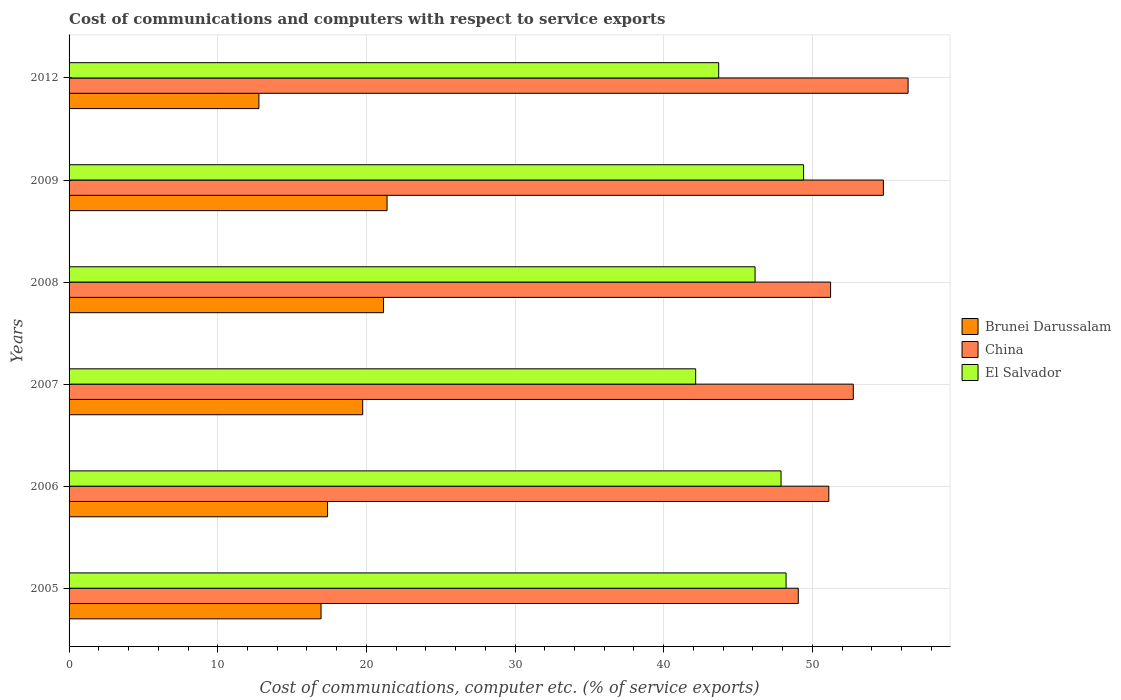How many different coloured bars are there?
Give a very brief answer. 3. Are the number of bars per tick equal to the number of legend labels?
Offer a very short reply. Yes. Are the number of bars on each tick of the Y-axis equal?
Offer a very short reply. Yes. What is the cost of communications and computers in El Salvador in 2005?
Your answer should be very brief. 48.23. Across all years, what is the maximum cost of communications and computers in China?
Keep it short and to the point. 56.44. Across all years, what is the minimum cost of communications and computers in China?
Provide a short and direct response. 49.06. What is the total cost of communications and computers in El Salvador in the graph?
Your answer should be very brief. 277.54. What is the difference between the cost of communications and computers in El Salvador in 2009 and that in 2012?
Keep it short and to the point. 5.71. What is the difference between the cost of communications and computers in El Salvador in 2005 and the cost of communications and computers in China in 2007?
Provide a succinct answer. -4.52. What is the average cost of communications and computers in Brunei Darussalam per year?
Make the answer very short. 18.23. In the year 2006, what is the difference between the cost of communications and computers in China and cost of communications and computers in Brunei Darussalam?
Give a very brief answer. 33.72. What is the ratio of the cost of communications and computers in China in 2006 to that in 2007?
Provide a short and direct response. 0.97. Is the cost of communications and computers in Brunei Darussalam in 2005 less than that in 2009?
Offer a very short reply. Yes. Is the difference between the cost of communications and computers in China in 2005 and 2007 greater than the difference between the cost of communications and computers in Brunei Darussalam in 2005 and 2007?
Offer a terse response. No. What is the difference between the highest and the second highest cost of communications and computers in Brunei Darussalam?
Ensure brevity in your answer.  0.24. What is the difference between the highest and the lowest cost of communications and computers in China?
Provide a succinct answer. 7.39. In how many years, is the cost of communications and computers in Brunei Darussalam greater than the average cost of communications and computers in Brunei Darussalam taken over all years?
Provide a short and direct response. 3. Is the sum of the cost of communications and computers in China in 2006 and 2012 greater than the maximum cost of communications and computers in El Salvador across all years?
Make the answer very short. Yes. What does the 3rd bar from the top in 2009 represents?
Ensure brevity in your answer.  Brunei Darussalam. What does the 3rd bar from the bottom in 2008 represents?
Make the answer very short. El Salvador. Are all the bars in the graph horizontal?
Give a very brief answer. Yes. What is the difference between two consecutive major ticks on the X-axis?
Your response must be concise. 10. Does the graph contain any zero values?
Keep it short and to the point. No. How are the legend labels stacked?
Provide a short and direct response. Vertical. What is the title of the graph?
Provide a short and direct response. Cost of communications and computers with respect to service exports. Does "France" appear as one of the legend labels in the graph?
Your answer should be compact. No. What is the label or title of the X-axis?
Your answer should be very brief. Cost of communications, computer etc. (% of service exports). What is the Cost of communications, computer etc. (% of service exports) of Brunei Darussalam in 2005?
Give a very brief answer. 16.95. What is the Cost of communications, computer etc. (% of service exports) of China in 2005?
Give a very brief answer. 49.06. What is the Cost of communications, computer etc. (% of service exports) of El Salvador in 2005?
Give a very brief answer. 48.23. What is the Cost of communications, computer etc. (% of service exports) in Brunei Darussalam in 2006?
Ensure brevity in your answer.  17.39. What is the Cost of communications, computer etc. (% of service exports) in China in 2006?
Keep it short and to the point. 51.11. What is the Cost of communications, computer etc. (% of service exports) in El Salvador in 2006?
Your answer should be very brief. 47.89. What is the Cost of communications, computer etc. (% of service exports) of Brunei Darussalam in 2007?
Give a very brief answer. 19.75. What is the Cost of communications, computer etc. (% of service exports) of China in 2007?
Your answer should be very brief. 52.76. What is the Cost of communications, computer etc. (% of service exports) of El Salvador in 2007?
Your response must be concise. 42.15. What is the Cost of communications, computer etc. (% of service exports) in Brunei Darussalam in 2008?
Offer a very short reply. 21.15. What is the Cost of communications, computer etc. (% of service exports) of China in 2008?
Provide a succinct answer. 51.23. What is the Cost of communications, computer etc. (% of service exports) of El Salvador in 2008?
Your answer should be very brief. 46.15. What is the Cost of communications, computer etc. (% of service exports) in Brunei Darussalam in 2009?
Your answer should be very brief. 21.39. What is the Cost of communications, computer etc. (% of service exports) of China in 2009?
Offer a very short reply. 54.78. What is the Cost of communications, computer etc. (% of service exports) of El Salvador in 2009?
Ensure brevity in your answer.  49.41. What is the Cost of communications, computer etc. (% of service exports) in Brunei Darussalam in 2012?
Your answer should be very brief. 12.77. What is the Cost of communications, computer etc. (% of service exports) in China in 2012?
Give a very brief answer. 56.44. What is the Cost of communications, computer etc. (% of service exports) in El Salvador in 2012?
Provide a short and direct response. 43.7. Across all years, what is the maximum Cost of communications, computer etc. (% of service exports) in Brunei Darussalam?
Your answer should be compact. 21.39. Across all years, what is the maximum Cost of communications, computer etc. (% of service exports) in China?
Offer a very short reply. 56.44. Across all years, what is the maximum Cost of communications, computer etc. (% of service exports) in El Salvador?
Offer a terse response. 49.41. Across all years, what is the minimum Cost of communications, computer etc. (% of service exports) in Brunei Darussalam?
Offer a terse response. 12.77. Across all years, what is the minimum Cost of communications, computer etc. (% of service exports) of China?
Your answer should be very brief. 49.06. Across all years, what is the minimum Cost of communications, computer etc. (% of service exports) in El Salvador?
Provide a succinct answer. 42.15. What is the total Cost of communications, computer etc. (% of service exports) of Brunei Darussalam in the graph?
Provide a short and direct response. 109.41. What is the total Cost of communications, computer etc. (% of service exports) in China in the graph?
Provide a succinct answer. 315.36. What is the total Cost of communications, computer etc. (% of service exports) of El Salvador in the graph?
Your answer should be very brief. 277.54. What is the difference between the Cost of communications, computer etc. (% of service exports) in Brunei Darussalam in 2005 and that in 2006?
Offer a terse response. -0.44. What is the difference between the Cost of communications, computer etc. (% of service exports) in China in 2005 and that in 2006?
Keep it short and to the point. -2.05. What is the difference between the Cost of communications, computer etc. (% of service exports) of El Salvador in 2005 and that in 2006?
Give a very brief answer. 0.34. What is the difference between the Cost of communications, computer etc. (% of service exports) of Brunei Darussalam in 2005 and that in 2007?
Your answer should be compact. -2.8. What is the difference between the Cost of communications, computer etc. (% of service exports) of China in 2005 and that in 2007?
Provide a succinct answer. -3.7. What is the difference between the Cost of communications, computer etc. (% of service exports) in El Salvador in 2005 and that in 2007?
Offer a very short reply. 6.08. What is the difference between the Cost of communications, computer etc. (% of service exports) in Brunei Darussalam in 2005 and that in 2008?
Your response must be concise. -4.2. What is the difference between the Cost of communications, computer etc. (% of service exports) in China in 2005 and that in 2008?
Offer a terse response. -2.17. What is the difference between the Cost of communications, computer etc. (% of service exports) of El Salvador in 2005 and that in 2008?
Ensure brevity in your answer.  2.09. What is the difference between the Cost of communications, computer etc. (% of service exports) of Brunei Darussalam in 2005 and that in 2009?
Ensure brevity in your answer.  -4.44. What is the difference between the Cost of communications, computer etc. (% of service exports) in China in 2005 and that in 2009?
Your answer should be compact. -5.72. What is the difference between the Cost of communications, computer etc. (% of service exports) of El Salvador in 2005 and that in 2009?
Keep it short and to the point. -1.18. What is the difference between the Cost of communications, computer etc. (% of service exports) in Brunei Darussalam in 2005 and that in 2012?
Offer a terse response. 4.18. What is the difference between the Cost of communications, computer etc. (% of service exports) in China in 2005 and that in 2012?
Provide a short and direct response. -7.39. What is the difference between the Cost of communications, computer etc. (% of service exports) in El Salvador in 2005 and that in 2012?
Offer a very short reply. 4.53. What is the difference between the Cost of communications, computer etc. (% of service exports) of Brunei Darussalam in 2006 and that in 2007?
Make the answer very short. -2.37. What is the difference between the Cost of communications, computer etc. (% of service exports) of China in 2006 and that in 2007?
Make the answer very short. -1.65. What is the difference between the Cost of communications, computer etc. (% of service exports) in El Salvador in 2006 and that in 2007?
Ensure brevity in your answer.  5.74. What is the difference between the Cost of communications, computer etc. (% of service exports) of Brunei Darussalam in 2006 and that in 2008?
Offer a terse response. -3.77. What is the difference between the Cost of communications, computer etc. (% of service exports) in China in 2006 and that in 2008?
Your answer should be compact. -0.12. What is the difference between the Cost of communications, computer etc. (% of service exports) in El Salvador in 2006 and that in 2008?
Offer a very short reply. 1.75. What is the difference between the Cost of communications, computer etc. (% of service exports) in Brunei Darussalam in 2006 and that in 2009?
Your answer should be very brief. -4. What is the difference between the Cost of communications, computer etc. (% of service exports) of China in 2006 and that in 2009?
Your answer should be compact. -3.67. What is the difference between the Cost of communications, computer etc. (% of service exports) in El Salvador in 2006 and that in 2009?
Your answer should be very brief. -1.52. What is the difference between the Cost of communications, computer etc. (% of service exports) of Brunei Darussalam in 2006 and that in 2012?
Your response must be concise. 4.62. What is the difference between the Cost of communications, computer etc. (% of service exports) of China in 2006 and that in 2012?
Your response must be concise. -5.33. What is the difference between the Cost of communications, computer etc. (% of service exports) in El Salvador in 2006 and that in 2012?
Offer a terse response. 4.2. What is the difference between the Cost of communications, computer etc. (% of service exports) of Brunei Darussalam in 2007 and that in 2008?
Your answer should be very brief. -1.4. What is the difference between the Cost of communications, computer etc. (% of service exports) of China in 2007 and that in 2008?
Provide a succinct answer. 1.53. What is the difference between the Cost of communications, computer etc. (% of service exports) of El Salvador in 2007 and that in 2008?
Provide a succinct answer. -4. What is the difference between the Cost of communications, computer etc. (% of service exports) in Brunei Darussalam in 2007 and that in 2009?
Ensure brevity in your answer.  -1.64. What is the difference between the Cost of communications, computer etc. (% of service exports) in China in 2007 and that in 2009?
Keep it short and to the point. -2.02. What is the difference between the Cost of communications, computer etc. (% of service exports) in El Salvador in 2007 and that in 2009?
Offer a terse response. -7.26. What is the difference between the Cost of communications, computer etc. (% of service exports) of Brunei Darussalam in 2007 and that in 2012?
Offer a terse response. 6.98. What is the difference between the Cost of communications, computer etc. (% of service exports) in China in 2007 and that in 2012?
Offer a terse response. -3.69. What is the difference between the Cost of communications, computer etc. (% of service exports) in El Salvador in 2007 and that in 2012?
Ensure brevity in your answer.  -1.55. What is the difference between the Cost of communications, computer etc. (% of service exports) in Brunei Darussalam in 2008 and that in 2009?
Your answer should be compact. -0.24. What is the difference between the Cost of communications, computer etc. (% of service exports) of China in 2008 and that in 2009?
Ensure brevity in your answer.  -3.55. What is the difference between the Cost of communications, computer etc. (% of service exports) of El Salvador in 2008 and that in 2009?
Keep it short and to the point. -3.26. What is the difference between the Cost of communications, computer etc. (% of service exports) in Brunei Darussalam in 2008 and that in 2012?
Offer a very short reply. 8.38. What is the difference between the Cost of communications, computer etc. (% of service exports) of China in 2008 and that in 2012?
Give a very brief answer. -5.21. What is the difference between the Cost of communications, computer etc. (% of service exports) of El Salvador in 2008 and that in 2012?
Your answer should be compact. 2.45. What is the difference between the Cost of communications, computer etc. (% of service exports) in Brunei Darussalam in 2009 and that in 2012?
Ensure brevity in your answer.  8.62. What is the difference between the Cost of communications, computer etc. (% of service exports) of China in 2009 and that in 2012?
Your answer should be compact. -1.66. What is the difference between the Cost of communications, computer etc. (% of service exports) in El Salvador in 2009 and that in 2012?
Offer a terse response. 5.71. What is the difference between the Cost of communications, computer etc. (% of service exports) of Brunei Darussalam in 2005 and the Cost of communications, computer etc. (% of service exports) of China in 2006?
Give a very brief answer. -34.16. What is the difference between the Cost of communications, computer etc. (% of service exports) in Brunei Darussalam in 2005 and the Cost of communications, computer etc. (% of service exports) in El Salvador in 2006?
Your answer should be compact. -30.94. What is the difference between the Cost of communications, computer etc. (% of service exports) in China in 2005 and the Cost of communications, computer etc. (% of service exports) in El Salvador in 2006?
Your response must be concise. 1.16. What is the difference between the Cost of communications, computer etc. (% of service exports) in Brunei Darussalam in 2005 and the Cost of communications, computer etc. (% of service exports) in China in 2007?
Make the answer very short. -35.8. What is the difference between the Cost of communications, computer etc. (% of service exports) in Brunei Darussalam in 2005 and the Cost of communications, computer etc. (% of service exports) in El Salvador in 2007?
Offer a terse response. -25.2. What is the difference between the Cost of communications, computer etc. (% of service exports) of China in 2005 and the Cost of communications, computer etc. (% of service exports) of El Salvador in 2007?
Ensure brevity in your answer.  6.9. What is the difference between the Cost of communications, computer etc. (% of service exports) of Brunei Darussalam in 2005 and the Cost of communications, computer etc. (% of service exports) of China in 2008?
Keep it short and to the point. -34.28. What is the difference between the Cost of communications, computer etc. (% of service exports) in Brunei Darussalam in 2005 and the Cost of communications, computer etc. (% of service exports) in El Salvador in 2008?
Give a very brief answer. -29.2. What is the difference between the Cost of communications, computer etc. (% of service exports) of China in 2005 and the Cost of communications, computer etc. (% of service exports) of El Salvador in 2008?
Offer a terse response. 2.91. What is the difference between the Cost of communications, computer etc. (% of service exports) in Brunei Darussalam in 2005 and the Cost of communications, computer etc. (% of service exports) in China in 2009?
Keep it short and to the point. -37.83. What is the difference between the Cost of communications, computer etc. (% of service exports) in Brunei Darussalam in 2005 and the Cost of communications, computer etc. (% of service exports) in El Salvador in 2009?
Offer a terse response. -32.46. What is the difference between the Cost of communications, computer etc. (% of service exports) of China in 2005 and the Cost of communications, computer etc. (% of service exports) of El Salvador in 2009?
Your answer should be compact. -0.36. What is the difference between the Cost of communications, computer etc. (% of service exports) of Brunei Darussalam in 2005 and the Cost of communications, computer etc. (% of service exports) of China in 2012?
Provide a succinct answer. -39.49. What is the difference between the Cost of communications, computer etc. (% of service exports) in Brunei Darussalam in 2005 and the Cost of communications, computer etc. (% of service exports) in El Salvador in 2012?
Provide a succinct answer. -26.75. What is the difference between the Cost of communications, computer etc. (% of service exports) of China in 2005 and the Cost of communications, computer etc. (% of service exports) of El Salvador in 2012?
Provide a succinct answer. 5.36. What is the difference between the Cost of communications, computer etc. (% of service exports) in Brunei Darussalam in 2006 and the Cost of communications, computer etc. (% of service exports) in China in 2007?
Ensure brevity in your answer.  -35.37. What is the difference between the Cost of communications, computer etc. (% of service exports) of Brunei Darussalam in 2006 and the Cost of communications, computer etc. (% of service exports) of El Salvador in 2007?
Give a very brief answer. -24.76. What is the difference between the Cost of communications, computer etc. (% of service exports) in China in 2006 and the Cost of communications, computer etc. (% of service exports) in El Salvador in 2007?
Ensure brevity in your answer.  8.96. What is the difference between the Cost of communications, computer etc. (% of service exports) of Brunei Darussalam in 2006 and the Cost of communications, computer etc. (% of service exports) of China in 2008?
Ensure brevity in your answer.  -33.84. What is the difference between the Cost of communications, computer etc. (% of service exports) in Brunei Darussalam in 2006 and the Cost of communications, computer etc. (% of service exports) in El Salvador in 2008?
Give a very brief answer. -28.76. What is the difference between the Cost of communications, computer etc. (% of service exports) of China in 2006 and the Cost of communications, computer etc. (% of service exports) of El Salvador in 2008?
Your response must be concise. 4.96. What is the difference between the Cost of communications, computer etc. (% of service exports) in Brunei Darussalam in 2006 and the Cost of communications, computer etc. (% of service exports) in China in 2009?
Provide a short and direct response. -37.39. What is the difference between the Cost of communications, computer etc. (% of service exports) in Brunei Darussalam in 2006 and the Cost of communications, computer etc. (% of service exports) in El Salvador in 2009?
Provide a succinct answer. -32.02. What is the difference between the Cost of communications, computer etc. (% of service exports) of China in 2006 and the Cost of communications, computer etc. (% of service exports) of El Salvador in 2009?
Make the answer very short. 1.7. What is the difference between the Cost of communications, computer etc. (% of service exports) in Brunei Darussalam in 2006 and the Cost of communications, computer etc. (% of service exports) in China in 2012?
Ensure brevity in your answer.  -39.05. What is the difference between the Cost of communications, computer etc. (% of service exports) of Brunei Darussalam in 2006 and the Cost of communications, computer etc. (% of service exports) of El Salvador in 2012?
Offer a very short reply. -26.31. What is the difference between the Cost of communications, computer etc. (% of service exports) in China in 2006 and the Cost of communications, computer etc. (% of service exports) in El Salvador in 2012?
Offer a terse response. 7.41. What is the difference between the Cost of communications, computer etc. (% of service exports) of Brunei Darussalam in 2007 and the Cost of communications, computer etc. (% of service exports) of China in 2008?
Offer a terse response. -31.47. What is the difference between the Cost of communications, computer etc. (% of service exports) of Brunei Darussalam in 2007 and the Cost of communications, computer etc. (% of service exports) of El Salvador in 2008?
Provide a short and direct response. -26.39. What is the difference between the Cost of communications, computer etc. (% of service exports) in China in 2007 and the Cost of communications, computer etc. (% of service exports) in El Salvador in 2008?
Your answer should be very brief. 6.61. What is the difference between the Cost of communications, computer etc. (% of service exports) in Brunei Darussalam in 2007 and the Cost of communications, computer etc. (% of service exports) in China in 2009?
Provide a succinct answer. -35.02. What is the difference between the Cost of communications, computer etc. (% of service exports) of Brunei Darussalam in 2007 and the Cost of communications, computer etc. (% of service exports) of El Salvador in 2009?
Ensure brevity in your answer.  -29.66. What is the difference between the Cost of communications, computer etc. (% of service exports) in China in 2007 and the Cost of communications, computer etc. (% of service exports) in El Salvador in 2009?
Make the answer very short. 3.34. What is the difference between the Cost of communications, computer etc. (% of service exports) of Brunei Darussalam in 2007 and the Cost of communications, computer etc. (% of service exports) of China in 2012?
Provide a succinct answer. -36.69. What is the difference between the Cost of communications, computer etc. (% of service exports) of Brunei Darussalam in 2007 and the Cost of communications, computer etc. (% of service exports) of El Salvador in 2012?
Your answer should be compact. -23.95. What is the difference between the Cost of communications, computer etc. (% of service exports) in China in 2007 and the Cost of communications, computer etc. (% of service exports) in El Salvador in 2012?
Make the answer very short. 9.06. What is the difference between the Cost of communications, computer etc. (% of service exports) of Brunei Darussalam in 2008 and the Cost of communications, computer etc. (% of service exports) of China in 2009?
Provide a short and direct response. -33.62. What is the difference between the Cost of communications, computer etc. (% of service exports) in Brunei Darussalam in 2008 and the Cost of communications, computer etc. (% of service exports) in El Salvador in 2009?
Make the answer very short. -28.26. What is the difference between the Cost of communications, computer etc. (% of service exports) in China in 2008 and the Cost of communications, computer etc. (% of service exports) in El Salvador in 2009?
Your response must be concise. 1.82. What is the difference between the Cost of communications, computer etc. (% of service exports) in Brunei Darussalam in 2008 and the Cost of communications, computer etc. (% of service exports) in China in 2012?
Provide a short and direct response. -35.29. What is the difference between the Cost of communications, computer etc. (% of service exports) in Brunei Darussalam in 2008 and the Cost of communications, computer etc. (% of service exports) in El Salvador in 2012?
Your answer should be compact. -22.55. What is the difference between the Cost of communications, computer etc. (% of service exports) in China in 2008 and the Cost of communications, computer etc. (% of service exports) in El Salvador in 2012?
Provide a succinct answer. 7.53. What is the difference between the Cost of communications, computer etc. (% of service exports) in Brunei Darussalam in 2009 and the Cost of communications, computer etc. (% of service exports) in China in 2012?
Ensure brevity in your answer.  -35.05. What is the difference between the Cost of communications, computer etc. (% of service exports) in Brunei Darussalam in 2009 and the Cost of communications, computer etc. (% of service exports) in El Salvador in 2012?
Your response must be concise. -22.31. What is the difference between the Cost of communications, computer etc. (% of service exports) of China in 2009 and the Cost of communications, computer etc. (% of service exports) of El Salvador in 2012?
Offer a very short reply. 11.08. What is the average Cost of communications, computer etc. (% of service exports) of Brunei Darussalam per year?
Your answer should be very brief. 18.23. What is the average Cost of communications, computer etc. (% of service exports) in China per year?
Ensure brevity in your answer.  52.56. What is the average Cost of communications, computer etc. (% of service exports) of El Salvador per year?
Make the answer very short. 46.26. In the year 2005, what is the difference between the Cost of communications, computer etc. (% of service exports) of Brunei Darussalam and Cost of communications, computer etc. (% of service exports) of China?
Provide a succinct answer. -32.1. In the year 2005, what is the difference between the Cost of communications, computer etc. (% of service exports) of Brunei Darussalam and Cost of communications, computer etc. (% of service exports) of El Salvador?
Make the answer very short. -31.28. In the year 2005, what is the difference between the Cost of communications, computer etc. (% of service exports) of China and Cost of communications, computer etc. (% of service exports) of El Salvador?
Make the answer very short. 0.82. In the year 2006, what is the difference between the Cost of communications, computer etc. (% of service exports) in Brunei Darussalam and Cost of communications, computer etc. (% of service exports) in China?
Keep it short and to the point. -33.72. In the year 2006, what is the difference between the Cost of communications, computer etc. (% of service exports) in Brunei Darussalam and Cost of communications, computer etc. (% of service exports) in El Salvador?
Keep it short and to the point. -30.51. In the year 2006, what is the difference between the Cost of communications, computer etc. (% of service exports) in China and Cost of communications, computer etc. (% of service exports) in El Salvador?
Your response must be concise. 3.21. In the year 2007, what is the difference between the Cost of communications, computer etc. (% of service exports) in Brunei Darussalam and Cost of communications, computer etc. (% of service exports) in China?
Give a very brief answer. -33. In the year 2007, what is the difference between the Cost of communications, computer etc. (% of service exports) of Brunei Darussalam and Cost of communications, computer etc. (% of service exports) of El Salvador?
Provide a succinct answer. -22.4. In the year 2007, what is the difference between the Cost of communications, computer etc. (% of service exports) of China and Cost of communications, computer etc. (% of service exports) of El Salvador?
Your answer should be compact. 10.6. In the year 2008, what is the difference between the Cost of communications, computer etc. (% of service exports) in Brunei Darussalam and Cost of communications, computer etc. (% of service exports) in China?
Provide a short and direct response. -30.07. In the year 2008, what is the difference between the Cost of communications, computer etc. (% of service exports) of Brunei Darussalam and Cost of communications, computer etc. (% of service exports) of El Salvador?
Provide a succinct answer. -24.99. In the year 2008, what is the difference between the Cost of communications, computer etc. (% of service exports) in China and Cost of communications, computer etc. (% of service exports) in El Salvador?
Your answer should be very brief. 5.08. In the year 2009, what is the difference between the Cost of communications, computer etc. (% of service exports) of Brunei Darussalam and Cost of communications, computer etc. (% of service exports) of China?
Ensure brevity in your answer.  -33.39. In the year 2009, what is the difference between the Cost of communications, computer etc. (% of service exports) in Brunei Darussalam and Cost of communications, computer etc. (% of service exports) in El Salvador?
Offer a very short reply. -28.02. In the year 2009, what is the difference between the Cost of communications, computer etc. (% of service exports) in China and Cost of communications, computer etc. (% of service exports) in El Salvador?
Your answer should be very brief. 5.37. In the year 2012, what is the difference between the Cost of communications, computer etc. (% of service exports) in Brunei Darussalam and Cost of communications, computer etc. (% of service exports) in China?
Keep it short and to the point. -43.67. In the year 2012, what is the difference between the Cost of communications, computer etc. (% of service exports) in Brunei Darussalam and Cost of communications, computer etc. (% of service exports) in El Salvador?
Your response must be concise. -30.93. In the year 2012, what is the difference between the Cost of communications, computer etc. (% of service exports) of China and Cost of communications, computer etc. (% of service exports) of El Salvador?
Give a very brief answer. 12.74. What is the ratio of the Cost of communications, computer etc. (% of service exports) of Brunei Darussalam in 2005 to that in 2006?
Offer a terse response. 0.97. What is the ratio of the Cost of communications, computer etc. (% of service exports) of China in 2005 to that in 2006?
Provide a short and direct response. 0.96. What is the ratio of the Cost of communications, computer etc. (% of service exports) of El Salvador in 2005 to that in 2006?
Ensure brevity in your answer.  1.01. What is the ratio of the Cost of communications, computer etc. (% of service exports) in Brunei Darussalam in 2005 to that in 2007?
Keep it short and to the point. 0.86. What is the ratio of the Cost of communications, computer etc. (% of service exports) in China in 2005 to that in 2007?
Keep it short and to the point. 0.93. What is the ratio of the Cost of communications, computer etc. (% of service exports) of El Salvador in 2005 to that in 2007?
Provide a succinct answer. 1.14. What is the ratio of the Cost of communications, computer etc. (% of service exports) in Brunei Darussalam in 2005 to that in 2008?
Ensure brevity in your answer.  0.8. What is the ratio of the Cost of communications, computer etc. (% of service exports) of China in 2005 to that in 2008?
Your answer should be very brief. 0.96. What is the ratio of the Cost of communications, computer etc. (% of service exports) in El Salvador in 2005 to that in 2008?
Ensure brevity in your answer.  1.05. What is the ratio of the Cost of communications, computer etc. (% of service exports) of Brunei Darussalam in 2005 to that in 2009?
Make the answer very short. 0.79. What is the ratio of the Cost of communications, computer etc. (% of service exports) of China in 2005 to that in 2009?
Your response must be concise. 0.9. What is the ratio of the Cost of communications, computer etc. (% of service exports) of El Salvador in 2005 to that in 2009?
Your answer should be compact. 0.98. What is the ratio of the Cost of communications, computer etc. (% of service exports) of Brunei Darussalam in 2005 to that in 2012?
Your answer should be compact. 1.33. What is the ratio of the Cost of communications, computer etc. (% of service exports) of China in 2005 to that in 2012?
Keep it short and to the point. 0.87. What is the ratio of the Cost of communications, computer etc. (% of service exports) in El Salvador in 2005 to that in 2012?
Your answer should be compact. 1.1. What is the ratio of the Cost of communications, computer etc. (% of service exports) in Brunei Darussalam in 2006 to that in 2007?
Your response must be concise. 0.88. What is the ratio of the Cost of communications, computer etc. (% of service exports) in China in 2006 to that in 2007?
Make the answer very short. 0.97. What is the ratio of the Cost of communications, computer etc. (% of service exports) of El Salvador in 2006 to that in 2007?
Provide a succinct answer. 1.14. What is the ratio of the Cost of communications, computer etc. (% of service exports) of Brunei Darussalam in 2006 to that in 2008?
Give a very brief answer. 0.82. What is the ratio of the Cost of communications, computer etc. (% of service exports) of El Salvador in 2006 to that in 2008?
Provide a succinct answer. 1.04. What is the ratio of the Cost of communications, computer etc. (% of service exports) in Brunei Darussalam in 2006 to that in 2009?
Offer a very short reply. 0.81. What is the ratio of the Cost of communications, computer etc. (% of service exports) of China in 2006 to that in 2009?
Provide a succinct answer. 0.93. What is the ratio of the Cost of communications, computer etc. (% of service exports) of El Salvador in 2006 to that in 2009?
Your answer should be very brief. 0.97. What is the ratio of the Cost of communications, computer etc. (% of service exports) in Brunei Darussalam in 2006 to that in 2012?
Make the answer very short. 1.36. What is the ratio of the Cost of communications, computer etc. (% of service exports) in China in 2006 to that in 2012?
Keep it short and to the point. 0.91. What is the ratio of the Cost of communications, computer etc. (% of service exports) in El Salvador in 2006 to that in 2012?
Your answer should be compact. 1.1. What is the ratio of the Cost of communications, computer etc. (% of service exports) of Brunei Darussalam in 2007 to that in 2008?
Your answer should be compact. 0.93. What is the ratio of the Cost of communications, computer etc. (% of service exports) in China in 2007 to that in 2008?
Offer a terse response. 1.03. What is the ratio of the Cost of communications, computer etc. (% of service exports) in El Salvador in 2007 to that in 2008?
Offer a very short reply. 0.91. What is the ratio of the Cost of communications, computer etc. (% of service exports) in Brunei Darussalam in 2007 to that in 2009?
Your answer should be compact. 0.92. What is the ratio of the Cost of communications, computer etc. (% of service exports) in China in 2007 to that in 2009?
Give a very brief answer. 0.96. What is the ratio of the Cost of communications, computer etc. (% of service exports) of El Salvador in 2007 to that in 2009?
Provide a short and direct response. 0.85. What is the ratio of the Cost of communications, computer etc. (% of service exports) in Brunei Darussalam in 2007 to that in 2012?
Your answer should be compact. 1.55. What is the ratio of the Cost of communications, computer etc. (% of service exports) in China in 2007 to that in 2012?
Keep it short and to the point. 0.93. What is the ratio of the Cost of communications, computer etc. (% of service exports) in El Salvador in 2007 to that in 2012?
Offer a very short reply. 0.96. What is the ratio of the Cost of communications, computer etc. (% of service exports) of Brunei Darussalam in 2008 to that in 2009?
Offer a very short reply. 0.99. What is the ratio of the Cost of communications, computer etc. (% of service exports) in China in 2008 to that in 2009?
Ensure brevity in your answer.  0.94. What is the ratio of the Cost of communications, computer etc. (% of service exports) in El Salvador in 2008 to that in 2009?
Give a very brief answer. 0.93. What is the ratio of the Cost of communications, computer etc. (% of service exports) of Brunei Darussalam in 2008 to that in 2012?
Offer a terse response. 1.66. What is the ratio of the Cost of communications, computer etc. (% of service exports) in China in 2008 to that in 2012?
Provide a succinct answer. 0.91. What is the ratio of the Cost of communications, computer etc. (% of service exports) of El Salvador in 2008 to that in 2012?
Provide a short and direct response. 1.06. What is the ratio of the Cost of communications, computer etc. (% of service exports) of Brunei Darussalam in 2009 to that in 2012?
Your response must be concise. 1.68. What is the ratio of the Cost of communications, computer etc. (% of service exports) of China in 2009 to that in 2012?
Ensure brevity in your answer.  0.97. What is the ratio of the Cost of communications, computer etc. (% of service exports) in El Salvador in 2009 to that in 2012?
Give a very brief answer. 1.13. What is the difference between the highest and the second highest Cost of communications, computer etc. (% of service exports) of Brunei Darussalam?
Make the answer very short. 0.24. What is the difference between the highest and the second highest Cost of communications, computer etc. (% of service exports) in China?
Keep it short and to the point. 1.66. What is the difference between the highest and the second highest Cost of communications, computer etc. (% of service exports) in El Salvador?
Your answer should be compact. 1.18. What is the difference between the highest and the lowest Cost of communications, computer etc. (% of service exports) in Brunei Darussalam?
Offer a terse response. 8.62. What is the difference between the highest and the lowest Cost of communications, computer etc. (% of service exports) of China?
Offer a very short reply. 7.39. What is the difference between the highest and the lowest Cost of communications, computer etc. (% of service exports) in El Salvador?
Provide a succinct answer. 7.26. 